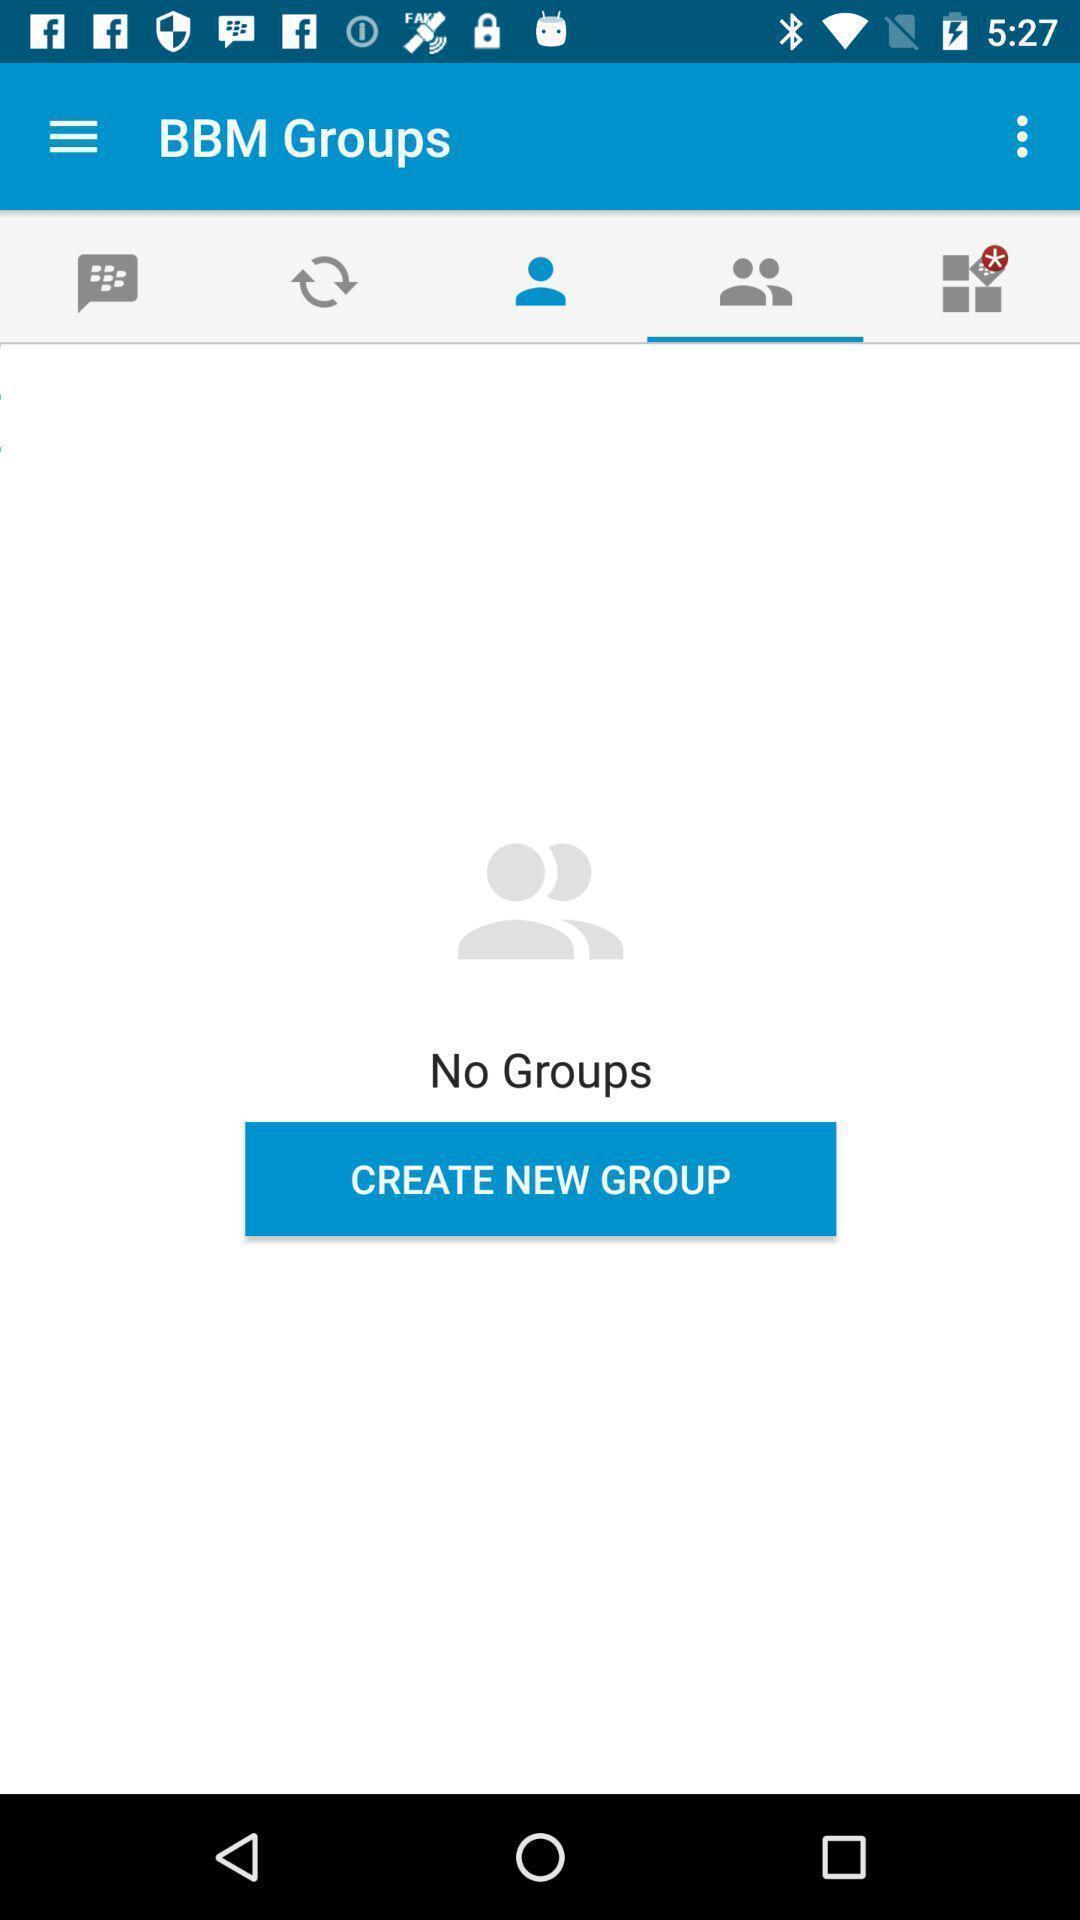Describe the visual elements of this screenshot. Screen shows multiple options in a communication app. 